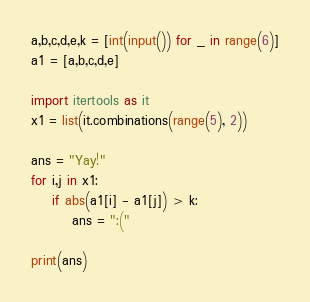<code> <loc_0><loc_0><loc_500><loc_500><_Python_>a,b,c,d,e,k = [int(input()) for _ in range(6)]
a1 = [a,b,c,d,e]

import itertools as it
x1 = list(it.combinations(range(5), 2))

ans = "Yay!"
for i,j in x1:
    if abs(a1[i] - a1[j]) > k:
        ans = ":("

print(ans)</code> 